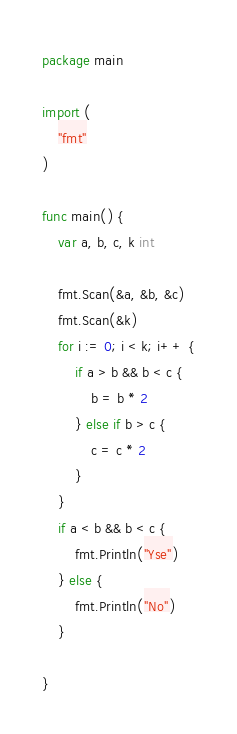Convert code to text. <code><loc_0><loc_0><loc_500><loc_500><_Go_>package main

import (
	"fmt"
)

func main() {
	var a, b, c, k int

	fmt.Scan(&a, &b, &c)
	fmt.Scan(&k)
	for i := 0; i < k; i++ {
		if a > b && b < c {
			b = b * 2
		} else if b > c {
			c = c * 2
		}
	}
	if a < b && b < c {
		fmt.Println("Yse")
	} else {
		fmt.Println("No")
	}

}
</code> 